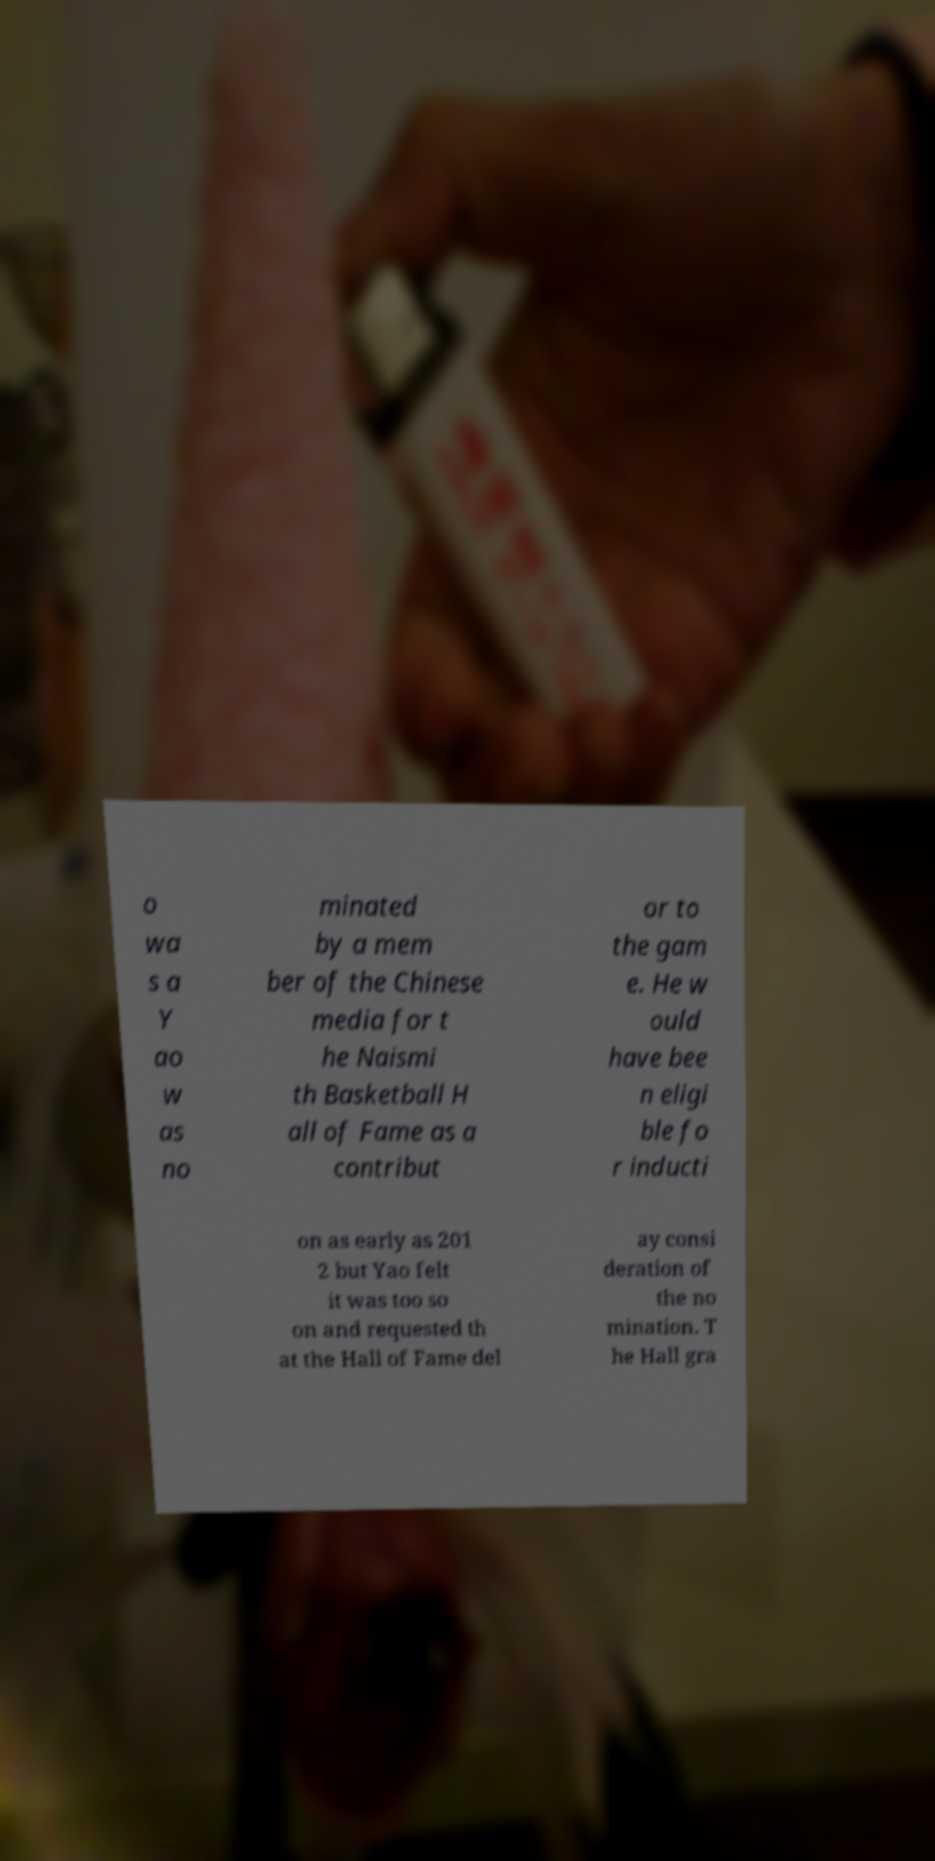Can you read and provide the text displayed in the image?This photo seems to have some interesting text. Can you extract and type it out for me? o wa s a Y ao w as no minated by a mem ber of the Chinese media for t he Naismi th Basketball H all of Fame as a contribut or to the gam e. He w ould have bee n eligi ble fo r inducti on as early as 201 2 but Yao felt it was too so on and requested th at the Hall of Fame del ay consi deration of the no mination. T he Hall gra 